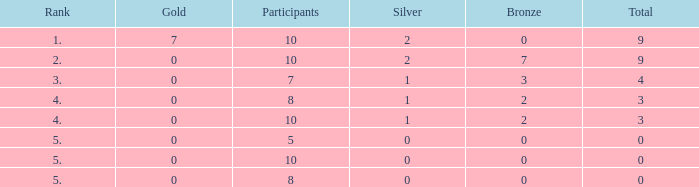What is the total number of Participants that has Silver that's smaller than 0? None. 